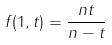<formula> <loc_0><loc_0><loc_500><loc_500>f ( 1 , t ) = \frac { n t } { n - t }</formula> 